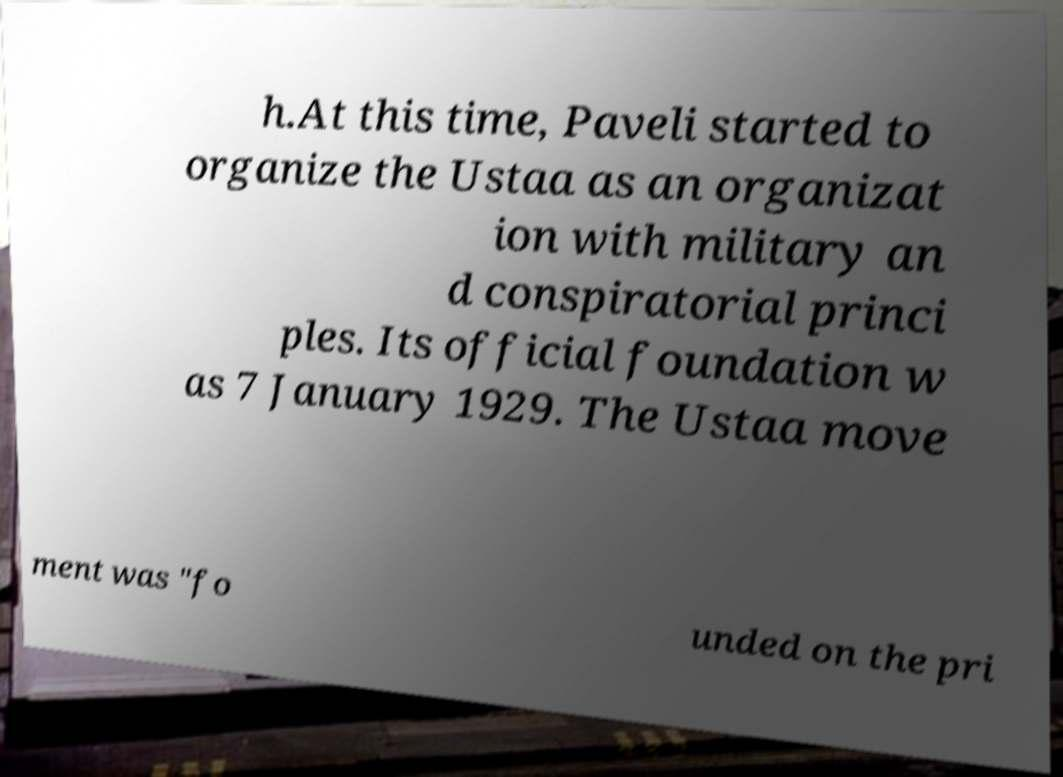Please identify and transcribe the text found in this image. h.At this time, Paveli started to organize the Ustaa as an organizat ion with military an d conspiratorial princi ples. Its official foundation w as 7 January 1929. The Ustaa move ment was "fo unded on the pri 